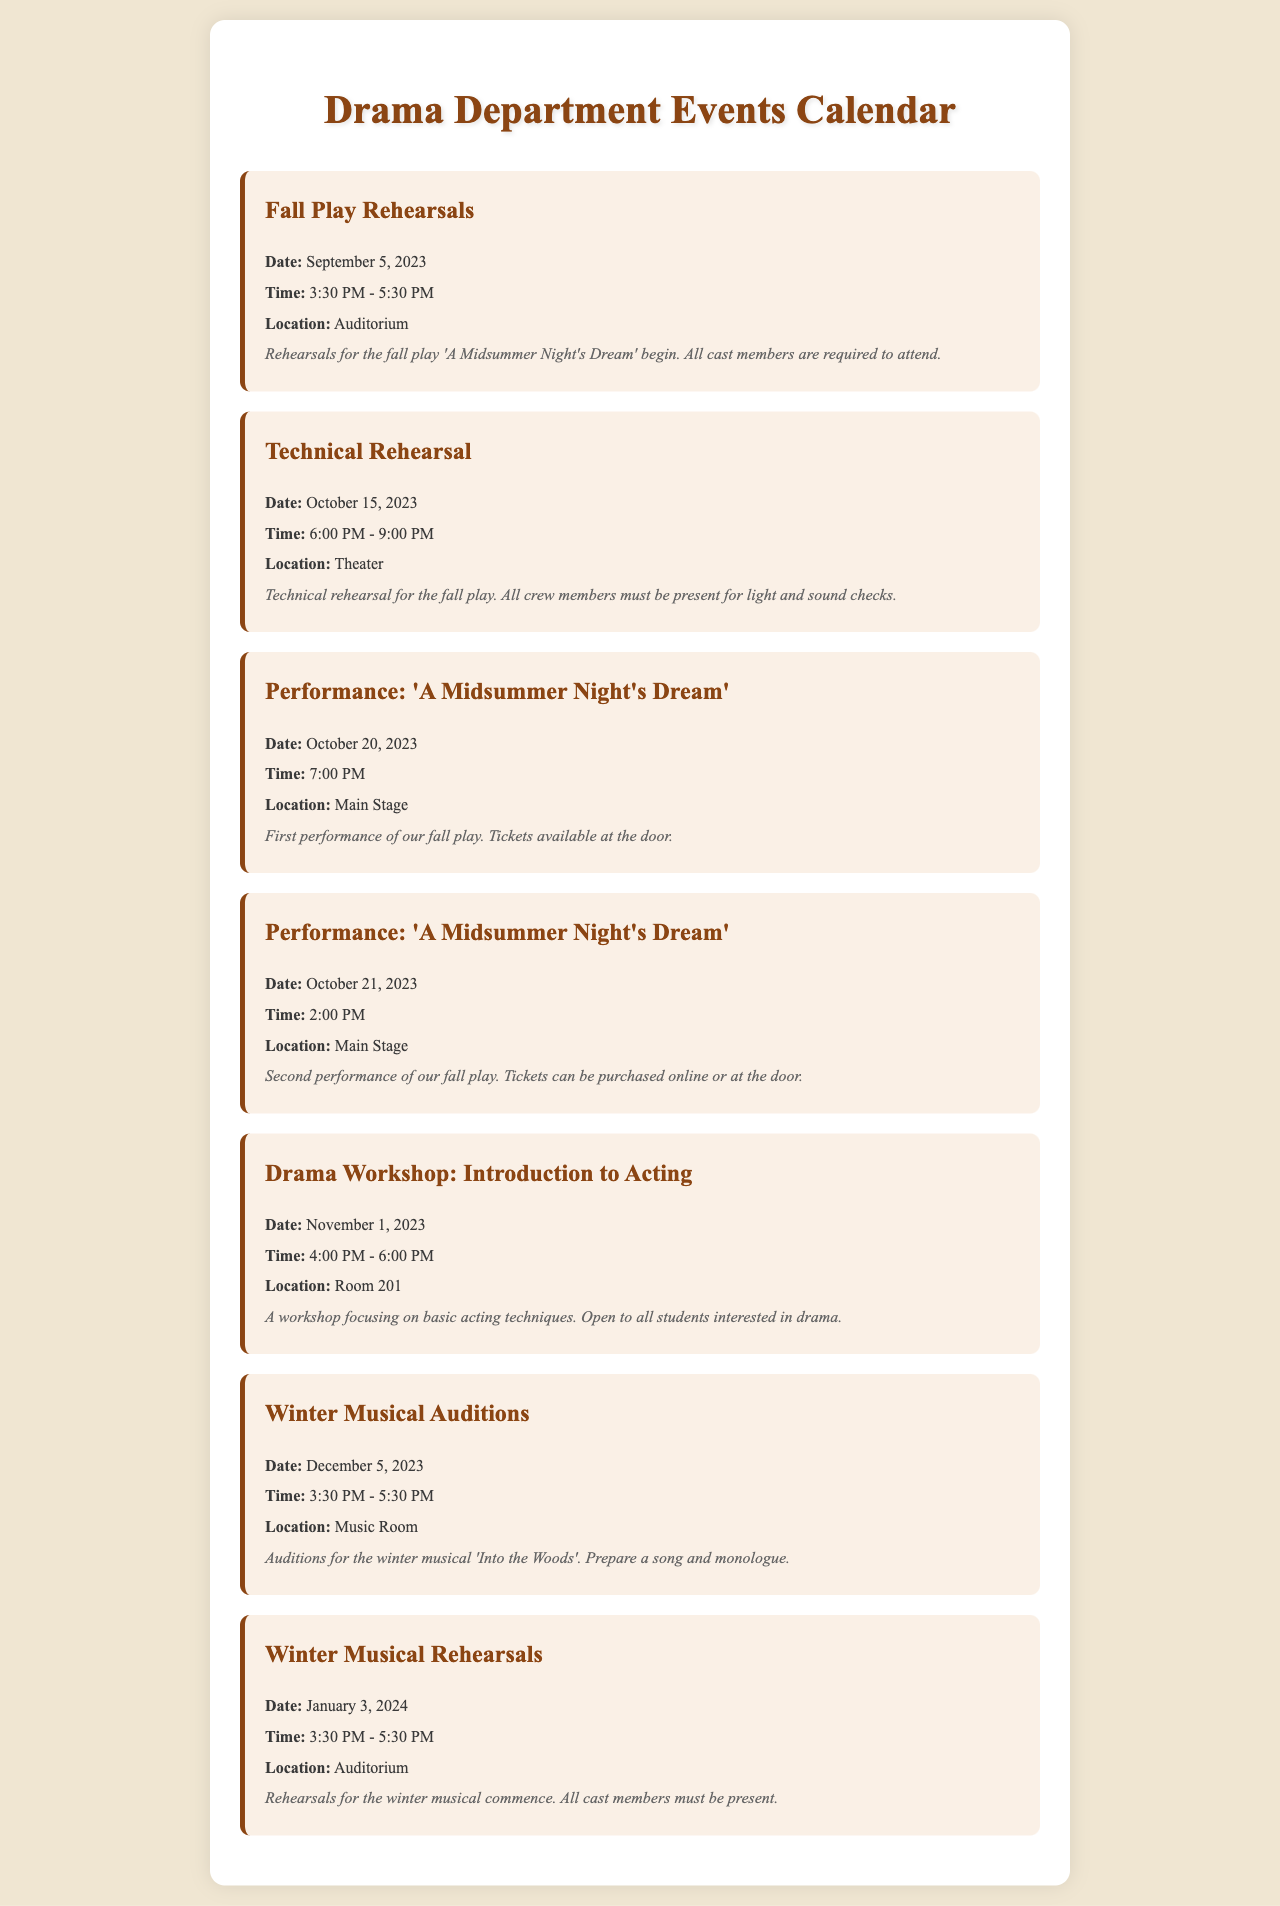What is the date for the first performance of 'A Midsummer Night's Dream'? The date of the first performance is listed in the document under the event for 'A Midsummer Night's Dream'.
Answer: October 20, 2023 What time does the Fall Play Rehearsals start? The start time for the Fall Play Rehearsals is provided in the event details.
Answer: 3:30 PM Where will the Winter Musical Auditions take place? The location for the Winter Musical Auditions is specified in the event description.
Answer: Music Room How many performances are scheduled for 'A Midsummer Night's Dream'? The document lists two performances of 'A Midsummer Night's Dream', which can be calculated by counting the performance events.
Answer: 2 What is the focus of the Drama Workshop on November 1, 2023? The focus of the Drama Workshop is mentioned in the event details, which describe the content of the workshop.
Answer: Basic acting techniques When do rehearsals for the Winter Musical begin? The document provides the starting date for the Winter Musical Rehearsals.
Answer: January 3, 2024 How long do the Fall Play Rehearsals last each day? The duration of the Fall Play Rehearsals can be calculated from the start and end times provided.
Answer: 2 hours Which play will be auditioned for in December? The name of the play being auditioned for is included in the event details for the Winter Musical Auditions.
Answer: Into the Woods What is the date of the Technical Rehearsal? The date for the Technical Rehearsal is explicitly mentioned in the document.
Answer: October 15, 2023 